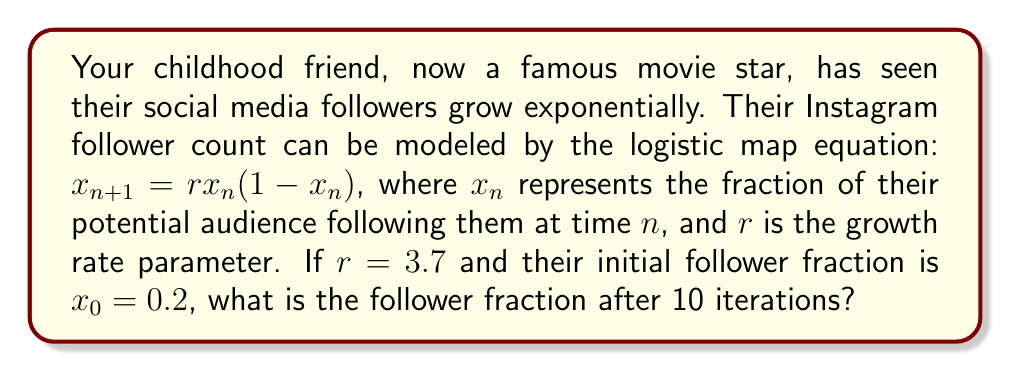What is the answer to this math problem? To solve this problem, we need to iterate the logistic map equation 10 times:

1) Start with $x_0 = 0.2$ and $r = 3.7$

2) For each iteration, calculate $x_{n+1} = rx_n(1-x_n)$:

   $x_1 = 3.7 \cdot 0.2 \cdot (1-0.2) = 0.592$
   
   $x_2 = 3.7 \cdot 0.592 \cdot (1-0.592) = 0.892775424$
   
   $x_3 = 3.7 \cdot 0.892775424 \cdot (1-0.892775424) = 0.355550839$
   
   $x_4 = 3.7 \cdot 0.355550839 \cdot (1-0.355550839) = 0.847352318$
   
   $x_5 = 3.7 \cdot 0.847352318 \cdot (1-0.847352318) = 0.478683979$
   
   $x_6 = 3.7 \cdot 0.478683979 \cdot (1-0.478683979) = 0.923500599$
   
   $x_7 = 3.7 \cdot 0.923500599 \cdot (1-0.923500599) = 0.261301369$
   
   $x_8 = 3.7 \cdot 0.261301369 \cdot (1-0.261301369) = 0.714767465$
   
   $x_9 = 3.7 \cdot 0.714767465 \cdot (1-0.714767465) = 0.754431371$
   
   $x_{10} = 3.7 \cdot 0.754431371 \cdot (1-0.754431371) = 0.686411736$

3) The follower fraction after 10 iterations is $x_{10} = 0.686411736$

This demonstrates the chaotic behavior of the logistic map for $r = 3.7$, as the values do not converge to a single point or cycle, but continue to vary unpredictably.
Answer: 0.686411736 